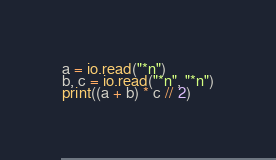Convert code to text. <code><loc_0><loc_0><loc_500><loc_500><_Lua_>a = io.read("*n")
b, c = io.read("*n", "*n")
print((a + b) * c // 2)</code> 